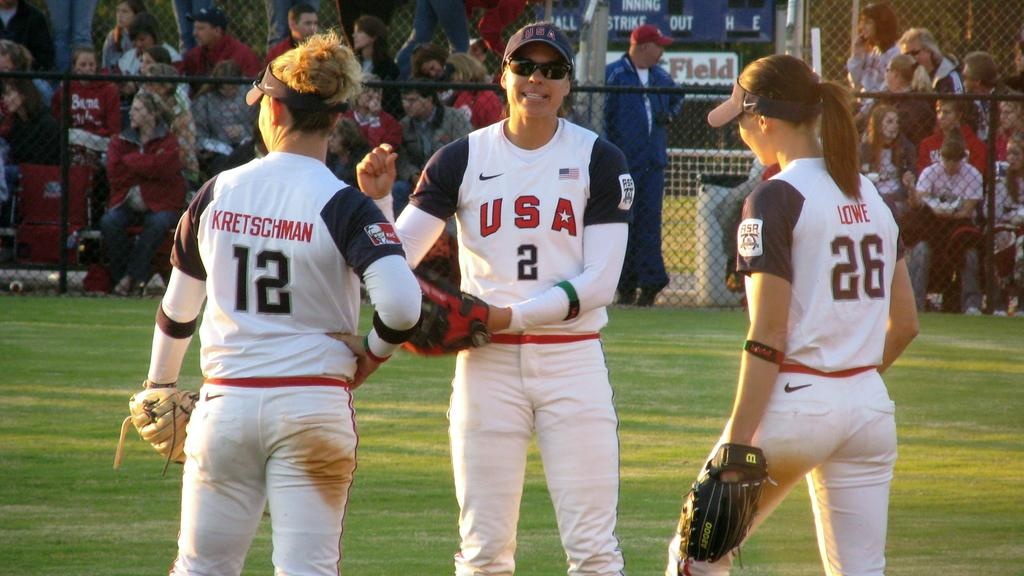<image>
Share a concise interpretation of the image provided. a few girls that are wearing jerseys that say USA 